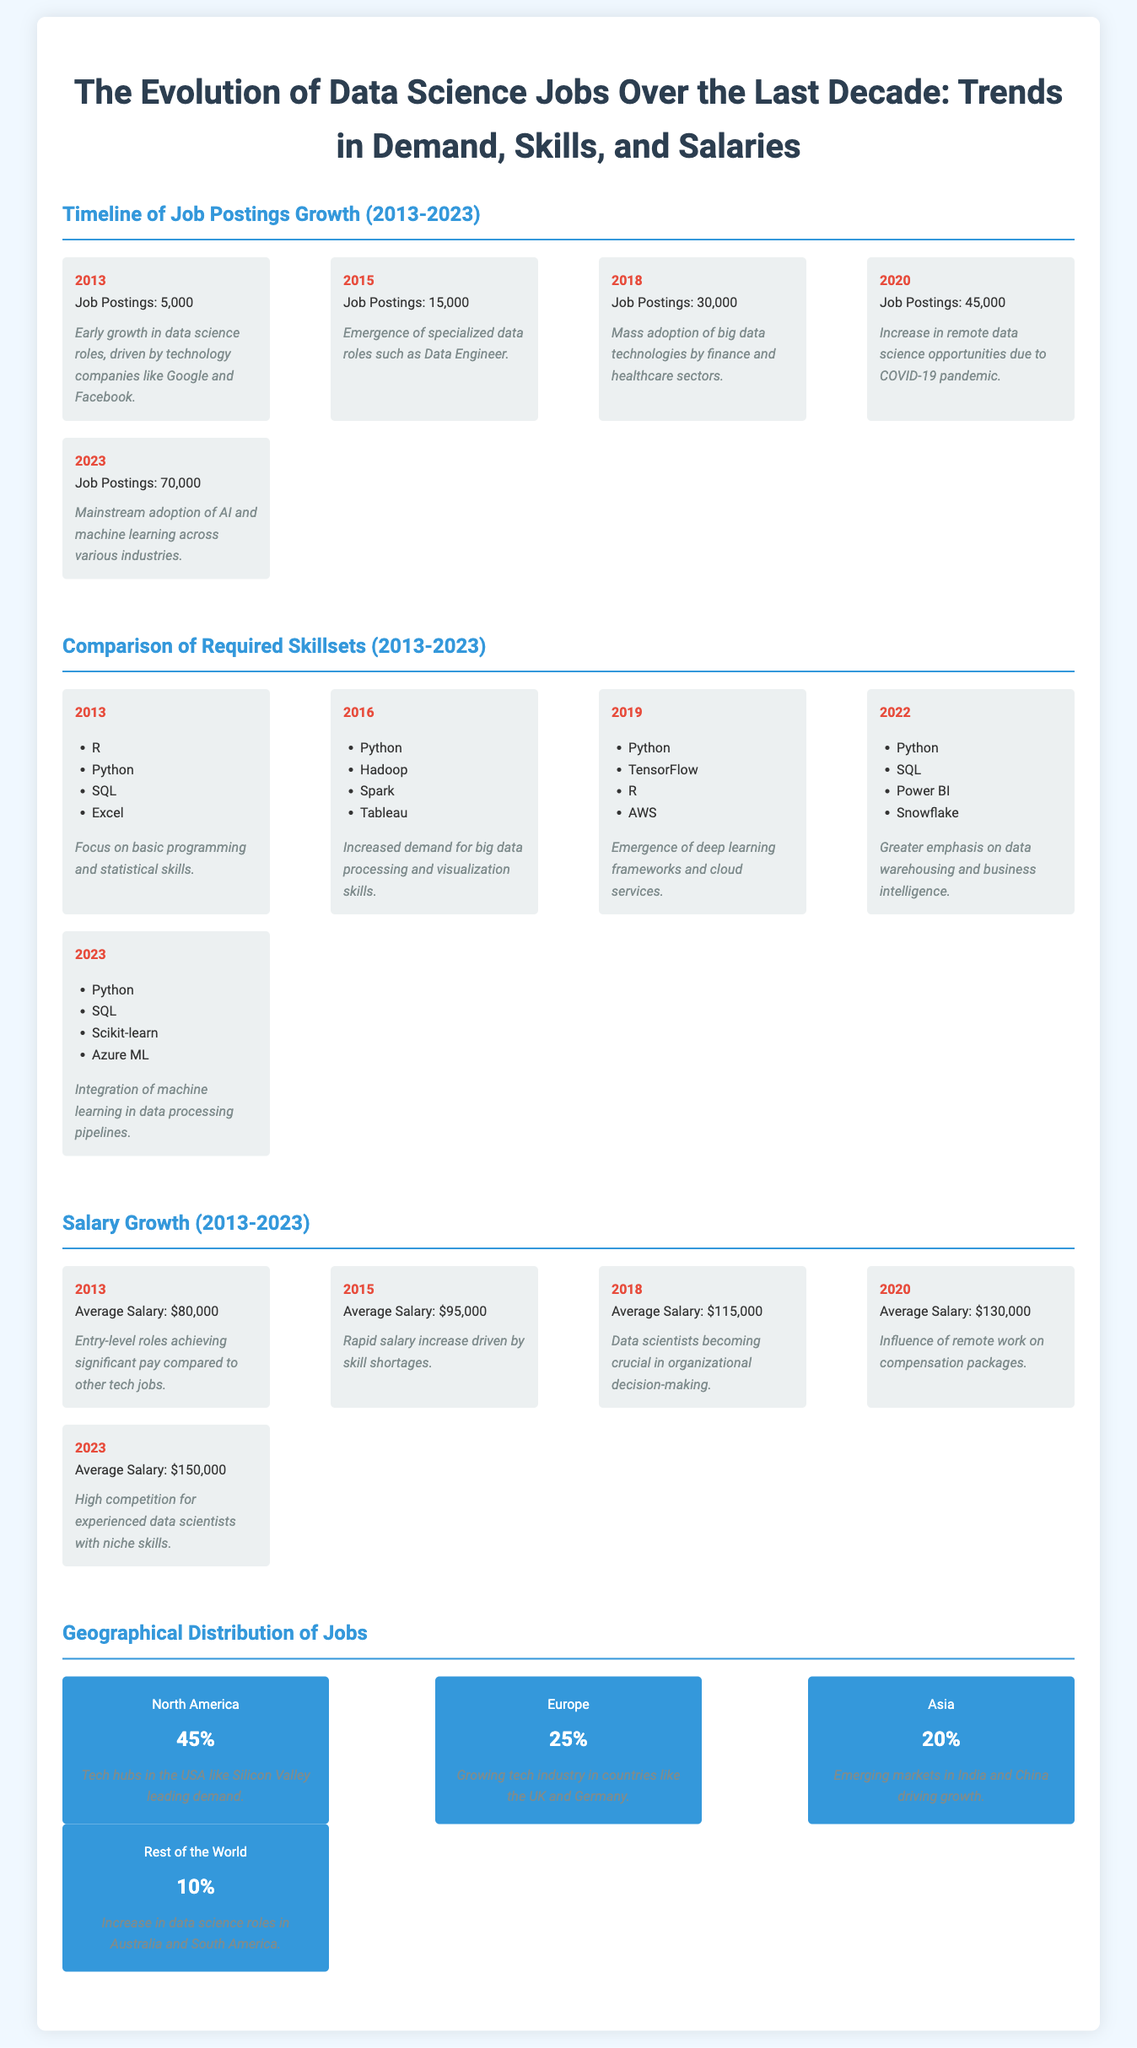What was the average salary in 2015? The average salary for data science jobs in 2015 is specifically stated as $95,000 in the document.
Answer: $95,000 Which year had the highest number of job postings? The document indicates that in 2023, there were 70,000 job postings, which is the highest compared to previous years.
Answer: 2023 What skill emerged in job requirements by 2019? By 2019, the skill TensorFlow was included as part of the required skill set, indicating the emergence of deep learning frameworks.
Answer: TensorFlow What percentage of data science jobs are in North America? The document states that 45% of data science jobs are located in North America.
Answer: 45% What notable event in 2020 influenced job opportunities? The document highlights the increase in remote data science opportunities due to the COVID-19 pandemic in 2020.
Answer: COVID-19 pandemic Which skill was emphasized in 2022 compared to earlier years? In 2022, there is a noted emphasis on data warehousing and business intelligence skills such as Power BI and Snowflake.
Answer: Data warehousing and business intelligence What was the total increase in average salary from 2013 to 2023? The document shows the average salary increased from $80,000 in 2013 to $150,000 in 2023, indicating a total increase of $70,000.
Answer: $70,000 Which geographical region has the lowest percentage of data science jobs? According to the document, the "Rest of the World" has the lowest percentage of data science jobs at 10%.
Answer: 10% 